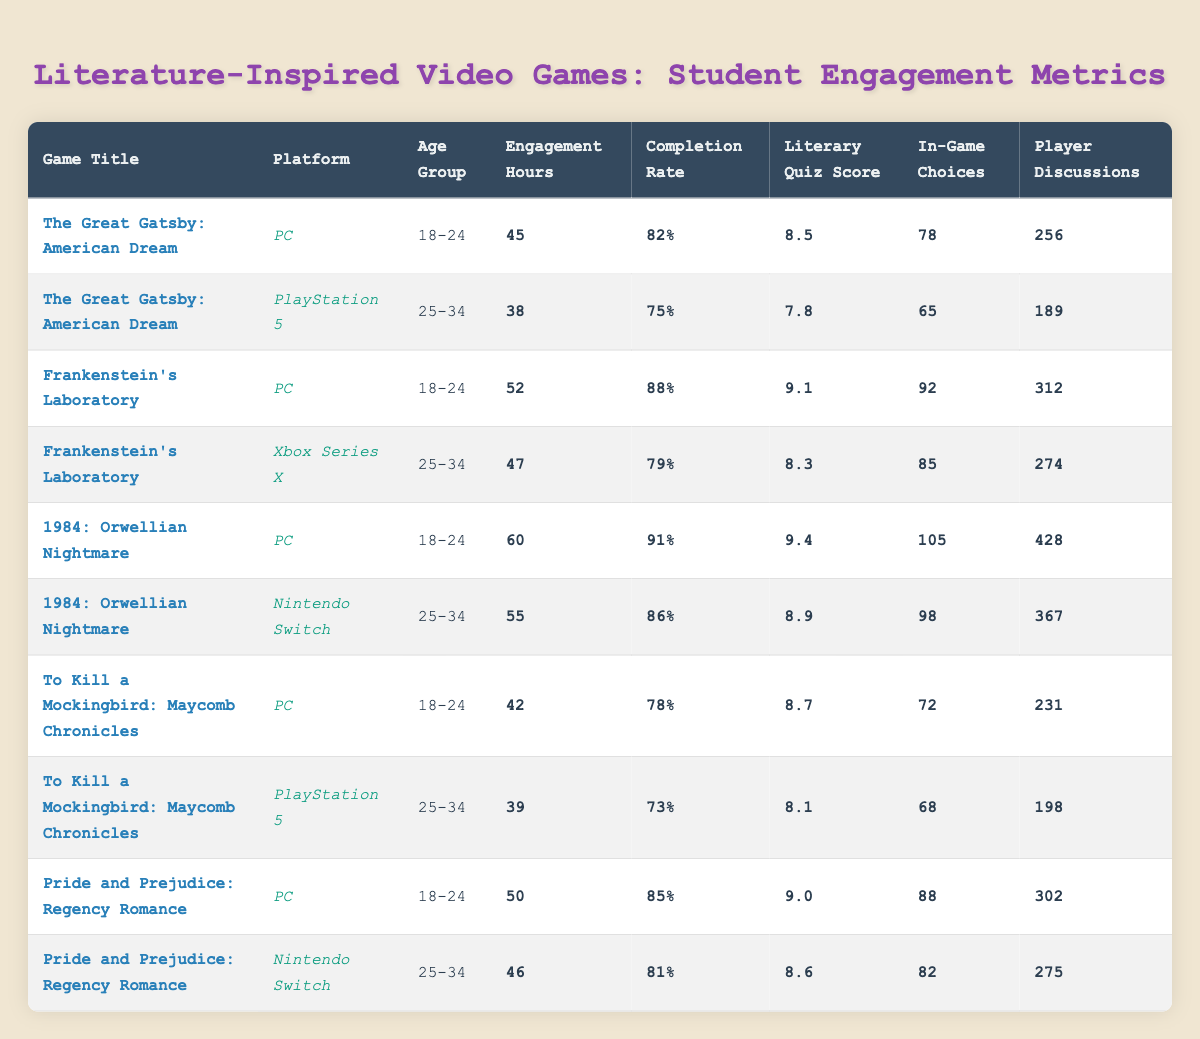What percentage of players completed "1984: Orwellian Nightmare" on PC? The table shows the completion rate for "1984: Orwellian Nightmare" on PC as 91%, which is directly stated in the completion rate column.
Answer: 91% What is the average engagement hours for games played by the 18-24 age group? The engagement hours for the 18-24 age group are as follows: 45 (The Great Gatsby), 52 (Frankenstein's Laboratory), 60 (1984: Orwellian Nightmare), 42 (To Kill a Mockingbird), and 50 (Pride and Prejudice). The sum is 45 + 52 + 60 + 42 + 50 = 249. There are 5 games, so the average is 249/5 = 49.8.
Answer: 49.8 Did players on PC generally have higher literary quiz scores compared to players on PlayStation 5 in the data? Players on PC had the following literary quiz scores: 8.5, 9.1, 9.4, 8.7, and 9.0. The scores on PlayStation 5 were 7.8 and 8.1. The average for PC is (8.5 + 9.1 + 9.4 + 8.7 + 9.0)/5 = 8.94. For PlayStation 5, the average is (7.8 + 8.1)/2 = 7.95. Since 8.94 is greater than 7.95, the statement is true.
Answer: Yes What is the difference in player discussions between "The Great Gatsby: American Dream" on PC and "To Kill a Mockingbird: Maycomb Chronicles" on PlayStation 5? "The Great Gatsby: American Dream" on PC has 256 player discussions. "To Kill a Mockingbird: Maycomb Chronicles" on PlayStation 5 has 198 player discussions. The difference is 256 - 198 = 58.
Answer: 58 Which age group had the highest completion rate in the table? The completion rates for age groups are: 82% (18-24, The Great Gatsby), 75% (25-34, The Great Gatsby), 88% (18-24, Frankenstein's Laboratory), 79% (25-34, Frankenstein's Laboratory), 91% (18-24, 1984), 86% (25-34, 1984), 78% (18-24, To Kill a Mockingbird), 73% (25-34, To Kill a Mockingbird), 85% (18-24, Pride and Prejudice), and 81% (25-34, Pride and Prejudice). The highest completion rate is 91% from the 18-24 age group for "1984: Orwellian Nightmare."
Answer: 18-24 What is the total number of in-game choices made by players in "Frankenstein's Laboratory"? For "Frankenstein's Laboratory," the total in-game choices are 92 (PC) and 85 (Xbox Series X). Adding these values gives 92 + 85 = 177.
Answer: 177 